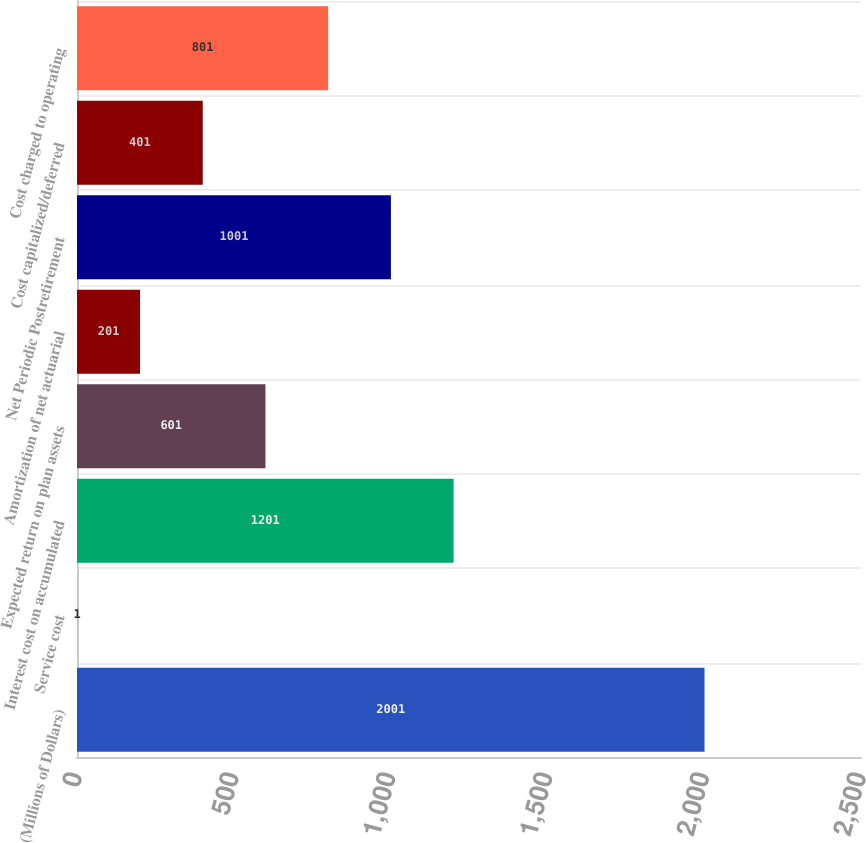Convert chart. <chart><loc_0><loc_0><loc_500><loc_500><bar_chart><fcel>(Millions of Dollars)<fcel>Service cost<fcel>Interest cost on accumulated<fcel>Expected return on plan assets<fcel>Amortization of net actuarial<fcel>Net Periodic Postretirement<fcel>Cost capitalized/deferred<fcel>Cost charged to operating<nl><fcel>2001<fcel>1<fcel>1201<fcel>601<fcel>201<fcel>1001<fcel>401<fcel>801<nl></chart> 